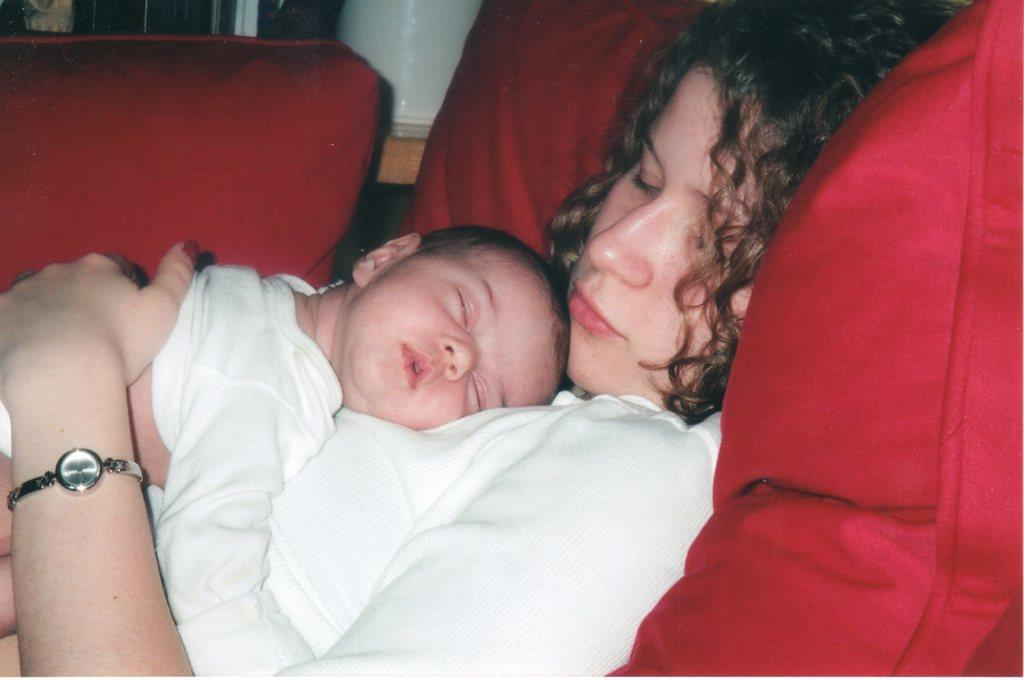Who is present in the image? There is a woman and a kid in the image. What are the woman and the kid wearing? The woman and the kid are both wearing white dresses. What are the woman and the kid doing in the image? The woman and the kid are sleeping. What can be seen on the right side of the image? There is a red pillow on the right side of the image. What is visible in the background of the image? There is a window in the background of the image. What type of cork can be seen in the mouth of the woman in the image? There is no cork present in the mouth of the woman in the image; she is sleeping. What is the woman pointing at in the image? The woman is not pointing at anything in the image; she is sleeping. 